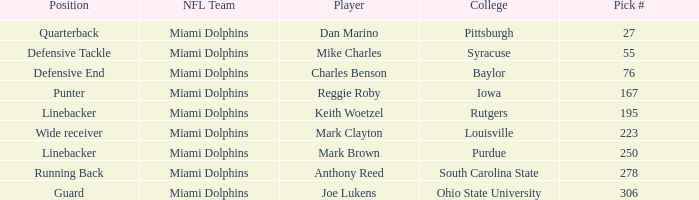Which College has Player Mark Brown and a Pick # greater than 195? Purdue. 